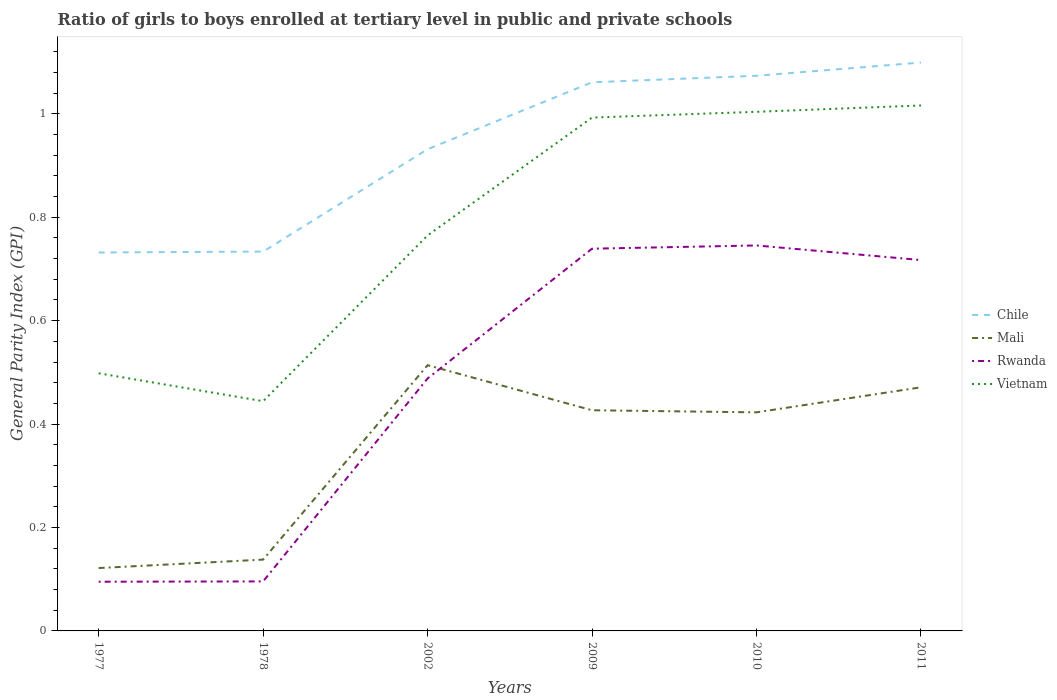Does the line corresponding to Rwanda intersect with the line corresponding to Vietnam?
Your response must be concise. No. Is the number of lines equal to the number of legend labels?
Your answer should be compact. Yes. Across all years, what is the maximum general parity index in Chile?
Make the answer very short. 0.73. What is the total general parity index in Vietnam in the graph?
Give a very brief answer. -0.02. What is the difference between the highest and the second highest general parity index in Rwanda?
Your response must be concise. 0.65. What is the difference between the highest and the lowest general parity index in Mali?
Your response must be concise. 4. Is the general parity index in Mali strictly greater than the general parity index in Chile over the years?
Make the answer very short. Yes. What is the difference between two consecutive major ticks on the Y-axis?
Provide a short and direct response. 0.2. Are the values on the major ticks of Y-axis written in scientific E-notation?
Give a very brief answer. No. Where does the legend appear in the graph?
Provide a succinct answer. Center right. How are the legend labels stacked?
Offer a terse response. Vertical. What is the title of the graph?
Your response must be concise. Ratio of girls to boys enrolled at tertiary level in public and private schools. What is the label or title of the Y-axis?
Provide a short and direct response. General Parity Index (GPI). What is the General Parity Index (GPI) in Chile in 1977?
Make the answer very short. 0.73. What is the General Parity Index (GPI) in Mali in 1977?
Ensure brevity in your answer.  0.12. What is the General Parity Index (GPI) in Rwanda in 1977?
Provide a short and direct response. 0.1. What is the General Parity Index (GPI) in Vietnam in 1977?
Your answer should be compact. 0.5. What is the General Parity Index (GPI) in Chile in 1978?
Provide a succinct answer. 0.73. What is the General Parity Index (GPI) in Mali in 1978?
Your answer should be compact. 0.14. What is the General Parity Index (GPI) of Rwanda in 1978?
Give a very brief answer. 0.1. What is the General Parity Index (GPI) of Vietnam in 1978?
Your answer should be compact. 0.44. What is the General Parity Index (GPI) of Chile in 2002?
Provide a short and direct response. 0.93. What is the General Parity Index (GPI) in Mali in 2002?
Ensure brevity in your answer.  0.51. What is the General Parity Index (GPI) in Rwanda in 2002?
Keep it short and to the point. 0.49. What is the General Parity Index (GPI) of Vietnam in 2002?
Provide a short and direct response. 0.76. What is the General Parity Index (GPI) of Chile in 2009?
Provide a succinct answer. 1.06. What is the General Parity Index (GPI) in Mali in 2009?
Ensure brevity in your answer.  0.43. What is the General Parity Index (GPI) of Rwanda in 2009?
Keep it short and to the point. 0.74. What is the General Parity Index (GPI) of Vietnam in 2009?
Provide a succinct answer. 0.99. What is the General Parity Index (GPI) in Chile in 2010?
Your response must be concise. 1.07. What is the General Parity Index (GPI) of Mali in 2010?
Ensure brevity in your answer.  0.42. What is the General Parity Index (GPI) in Rwanda in 2010?
Give a very brief answer. 0.75. What is the General Parity Index (GPI) of Vietnam in 2010?
Ensure brevity in your answer.  1. What is the General Parity Index (GPI) of Chile in 2011?
Ensure brevity in your answer.  1.1. What is the General Parity Index (GPI) of Mali in 2011?
Provide a succinct answer. 0.47. What is the General Parity Index (GPI) in Rwanda in 2011?
Your response must be concise. 0.72. What is the General Parity Index (GPI) of Vietnam in 2011?
Provide a short and direct response. 1.02. Across all years, what is the maximum General Parity Index (GPI) in Chile?
Make the answer very short. 1.1. Across all years, what is the maximum General Parity Index (GPI) in Mali?
Your answer should be very brief. 0.51. Across all years, what is the maximum General Parity Index (GPI) of Rwanda?
Your response must be concise. 0.75. Across all years, what is the maximum General Parity Index (GPI) of Vietnam?
Your answer should be compact. 1.02. Across all years, what is the minimum General Parity Index (GPI) of Chile?
Provide a short and direct response. 0.73. Across all years, what is the minimum General Parity Index (GPI) in Mali?
Give a very brief answer. 0.12. Across all years, what is the minimum General Parity Index (GPI) in Rwanda?
Offer a terse response. 0.1. Across all years, what is the minimum General Parity Index (GPI) of Vietnam?
Make the answer very short. 0.44. What is the total General Parity Index (GPI) in Chile in the graph?
Keep it short and to the point. 5.63. What is the total General Parity Index (GPI) of Mali in the graph?
Offer a very short reply. 2.09. What is the total General Parity Index (GPI) in Rwanda in the graph?
Your response must be concise. 2.88. What is the total General Parity Index (GPI) in Vietnam in the graph?
Provide a succinct answer. 4.72. What is the difference between the General Parity Index (GPI) in Chile in 1977 and that in 1978?
Make the answer very short. -0. What is the difference between the General Parity Index (GPI) in Mali in 1977 and that in 1978?
Make the answer very short. -0.02. What is the difference between the General Parity Index (GPI) of Rwanda in 1977 and that in 1978?
Offer a terse response. -0. What is the difference between the General Parity Index (GPI) in Vietnam in 1977 and that in 1978?
Your answer should be compact. 0.05. What is the difference between the General Parity Index (GPI) in Chile in 1977 and that in 2002?
Give a very brief answer. -0.2. What is the difference between the General Parity Index (GPI) of Mali in 1977 and that in 2002?
Keep it short and to the point. -0.39. What is the difference between the General Parity Index (GPI) of Rwanda in 1977 and that in 2002?
Your answer should be very brief. -0.39. What is the difference between the General Parity Index (GPI) of Vietnam in 1977 and that in 2002?
Keep it short and to the point. -0.27. What is the difference between the General Parity Index (GPI) in Chile in 1977 and that in 2009?
Your answer should be compact. -0.33. What is the difference between the General Parity Index (GPI) in Mali in 1977 and that in 2009?
Provide a short and direct response. -0.31. What is the difference between the General Parity Index (GPI) in Rwanda in 1977 and that in 2009?
Offer a terse response. -0.64. What is the difference between the General Parity Index (GPI) in Vietnam in 1977 and that in 2009?
Give a very brief answer. -0.49. What is the difference between the General Parity Index (GPI) of Chile in 1977 and that in 2010?
Your answer should be compact. -0.34. What is the difference between the General Parity Index (GPI) of Mali in 1977 and that in 2010?
Provide a succinct answer. -0.3. What is the difference between the General Parity Index (GPI) of Rwanda in 1977 and that in 2010?
Provide a short and direct response. -0.65. What is the difference between the General Parity Index (GPI) of Vietnam in 1977 and that in 2010?
Give a very brief answer. -0.51. What is the difference between the General Parity Index (GPI) of Chile in 1977 and that in 2011?
Keep it short and to the point. -0.37. What is the difference between the General Parity Index (GPI) of Mali in 1977 and that in 2011?
Your answer should be very brief. -0.35. What is the difference between the General Parity Index (GPI) of Rwanda in 1977 and that in 2011?
Make the answer very short. -0.62. What is the difference between the General Parity Index (GPI) of Vietnam in 1977 and that in 2011?
Your response must be concise. -0.52. What is the difference between the General Parity Index (GPI) in Chile in 1978 and that in 2002?
Provide a succinct answer. -0.2. What is the difference between the General Parity Index (GPI) of Mali in 1978 and that in 2002?
Offer a terse response. -0.38. What is the difference between the General Parity Index (GPI) of Rwanda in 1978 and that in 2002?
Offer a very short reply. -0.39. What is the difference between the General Parity Index (GPI) of Vietnam in 1978 and that in 2002?
Keep it short and to the point. -0.32. What is the difference between the General Parity Index (GPI) in Chile in 1978 and that in 2009?
Give a very brief answer. -0.33. What is the difference between the General Parity Index (GPI) in Mali in 1978 and that in 2009?
Your answer should be very brief. -0.29. What is the difference between the General Parity Index (GPI) of Rwanda in 1978 and that in 2009?
Provide a short and direct response. -0.64. What is the difference between the General Parity Index (GPI) in Vietnam in 1978 and that in 2009?
Your response must be concise. -0.55. What is the difference between the General Parity Index (GPI) of Chile in 1978 and that in 2010?
Give a very brief answer. -0.34. What is the difference between the General Parity Index (GPI) of Mali in 1978 and that in 2010?
Keep it short and to the point. -0.28. What is the difference between the General Parity Index (GPI) in Rwanda in 1978 and that in 2010?
Make the answer very short. -0.65. What is the difference between the General Parity Index (GPI) in Vietnam in 1978 and that in 2010?
Your answer should be compact. -0.56. What is the difference between the General Parity Index (GPI) in Chile in 1978 and that in 2011?
Your answer should be compact. -0.37. What is the difference between the General Parity Index (GPI) in Mali in 1978 and that in 2011?
Keep it short and to the point. -0.33. What is the difference between the General Parity Index (GPI) of Rwanda in 1978 and that in 2011?
Offer a terse response. -0.62. What is the difference between the General Parity Index (GPI) of Vietnam in 1978 and that in 2011?
Offer a terse response. -0.57. What is the difference between the General Parity Index (GPI) in Chile in 2002 and that in 2009?
Give a very brief answer. -0.13. What is the difference between the General Parity Index (GPI) in Mali in 2002 and that in 2009?
Ensure brevity in your answer.  0.09. What is the difference between the General Parity Index (GPI) in Rwanda in 2002 and that in 2009?
Offer a very short reply. -0.25. What is the difference between the General Parity Index (GPI) in Vietnam in 2002 and that in 2009?
Your answer should be compact. -0.23. What is the difference between the General Parity Index (GPI) in Chile in 2002 and that in 2010?
Give a very brief answer. -0.14. What is the difference between the General Parity Index (GPI) in Mali in 2002 and that in 2010?
Provide a short and direct response. 0.09. What is the difference between the General Parity Index (GPI) in Rwanda in 2002 and that in 2010?
Offer a terse response. -0.26. What is the difference between the General Parity Index (GPI) in Vietnam in 2002 and that in 2010?
Your response must be concise. -0.24. What is the difference between the General Parity Index (GPI) of Chile in 2002 and that in 2011?
Your answer should be compact. -0.17. What is the difference between the General Parity Index (GPI) in Mali in 2002 and that in 2011?
Ensure brevity in your answer.  0.04. What is the difference between the General Parity Index (GPI) in Rwanda in 2002 and that in 2011?
Your answer should be very brief. -0.23. What is the difference between the General Parity Index (GPI) in Vietnam in 2002 and that in 2011?
Offer a terse response. -0.25. What is the difference between the General Parity Index (GPI) in Chile in 2009 and that in 2010?
Offer a very short reply. -0.01. What is the difference between the General Parity Index (GPI) in Mali in 2009 and that in 2010?
Your response must be concise. 0. What is the difference between the General Parity Index (GPI) of Rwanda in 2009 and that in 2010?
Your answer should be very brief. -0.01. What is the difference between the General Parity Index (GPI) in Vietnam in 2009 and that in 2010?
Provide a succinct answer. -0.01. What is the difference between the General Parity Index (GPI) of Chile in 2009 and that in 2011?
Your answer should be very brief. -0.04. What is the difference between the General Parity Index (GPI) in Mali in 2009 and that in 2011?
Your response must be concise. -0.04. What is the difference between the General Parity Index (GPI) in Rwanda in 2009 and that in 2011?
Your response must be concise. 0.02. What is the difference between the General Parity Index (GPI) in Vietnam in 2009 and that in 2011?
Offer a terse response. -0.02. What is the difference between the General Parity Index (GPI) in Chile in 2010 and that in 2011?
Your answer should be very brief. -0.03. What is the difference between the General Parity Index (GPI) of Mali in 2010 and that in 2011?
Provide a succinct answer. -0.05. What is the difference between the General Parity Index (GPI) of Rwanda in 2010 and that in 2011?
Give a very brief answer. 0.03. What is the difference between the General Parity Index (GPI) in Vietnam in 2010 and that in 2011?
Keep it short and to the point. -0.01. What is the difference between the General Parity Index (GPI) in Chile in 1977 and the General Parity Index (GPI) in Mali in 1978?
Your answer should be compact. 0.59. What is the difference between the General Parity Index (GPI) in Chile in 1977 and the General Parity Index (GPI) in Rwanda in 1978?
Provide a succinct answer. 0.64. What is the difference between the General Parity Index (GPI) in Chile in 1977 and the General Parity Index (GPI) in Vietnam in 1978?
Keep it short and to the point. 0.29. What is the difference between the General Parity Index (GPI) of Mali in 1977 and the General Parity Index (GPI) of Rwanda in 1978?
Offer a terse response. 0.03. What is the difference between the General Parity Index (GPI) of Mali in 1977 and the General Parity Index (GPI) of Vietnam in 1978?
Give a very brief answer. -0.32. What is the difference between the General Parity Index (GPI) in Rwanda in 1977 and the General Parity Index (GPI) in Vietnam in 1978?
Provide a succinct answer. -0.35. What is the difference between the General Parity Index (GPI) in Chile in 1977 and the General Parity Index (GPI) in Mali in 2002?
Your response must be concise. 0.22. What is the difference between the General Parity Index (GPI) of Chile in 1977 and the General Parity Index (GPI) of Rwanda in 2002?
Provide a succinct answer. 0.24. What is the difference between the General Parity Index (GPI) of Chile in 1977 and the General Parity Index (GPI) of Vietnam in 2002?
Provide a succinct answer. -0.03. What is the difference between the General Parity Index (GPI) of Mali in 1977 and the General Parity Index (GPI) of Rwanda in 2002?
Keep it short and to the point. -0.37. What is the difference between the General Parity Index (GPI) in Mali in 1977 and the General Parity Index (GPI) in Vietnam in 2002?
Ensure brevity in your answer.  -0.64. What is the difference between the General Parity Index (GPI) of Rwanda in 1977 and the General Parity Index (GPI) of Vietnam in 2002?
Provide a short and direct response. -0.67. What is the difference between the General Parity Index (GPI) of Chile in 1977 and the General Parity Index (GPI) of Mali in 2009?
Provide a short and direct response. 0.31. What is the difference between the General Parity Index (GPI) in Chile in 1977 and the General Parity Index (GPI) in Rwanda in 2009?
Your response must be concise. -0.01. What is the difference between the General Parity Index (GPI) in Chile in 1977 and the General Parity Index (GPI) in Vietnam in 2009?
Your answer should be compact. -0.26. What is the difference between the General Parity Index (GPI) in Mali in 1977 and the General Parity Index (GPI) in Rwanda in 2009?
Provide a short and direct response. -0.62. What is the difference between the General Parity Index (GPI) in Mali in 1977 and the General Parity Index (GPI) in Vietnam in 2009?
Offer a very short reply. -0.87. What is the difference between the General Parity Index (GPI) in Rwanda in 1977 and the General Parity Index (GPI) in Vietnam in 2009?
Provide a short and direct response. -0.9. What is the difference between the General Parity Index (GPI) in Chile in 1977 and the General Parity Index (GPI) in Mali in 2010?
Offer a very short reply. 0.31. What is the difference between the General Parity Index (GPI) of Chile in 1977 and the General Parity Index (GPI) of Rwanda in 2010?
Offer a terse response. -0.01. What is the difference between the General Parity Index (GPI) in Chile in 1977 and the General Parity Index (GPI) in Vietnam in 2010?
Make the answer very short. -0.27. What is the difference between the General Parity Index (GPI) of Mali in 1977 and the General Parity Index (GPI) of Rwanda in 2010?
Ensure brevity in your answer.  -0.62. What is the difference between the General Parity Index (GPI) of Mali in 1977 and the General Parity Index (GPI) of Vietnam in 2010?
Offer a very short reply. -0.88. What is the difference between the General Parity Index (GPI) of Rwanda in 1977 and the General Parity Index (GPI) of Vietnam in 2010?
Your response must be concise. -0.91. What is the difference between the General Parity Index (GPI) in Chile in 1977 and the General Parity Index (GPI) in Mali in 2011?
Ensure brevity in your answer.  0.26. What is the difference between the General Parity Index (GPI) of Chile in 1977 and the General Parity Index (GPI) of Rwanda in 2011?
Make the answer very short. 0.01. What is the difference between the General Parity Index (GPI) in Chile in 1977 and the General Parity Index (GPI) in Vietnam in 2011?
Ensure brevity in your answer.  -0.28. What is the difference between the General Parity Index (GPI) of Mali in 1977 and the General Parity Index (GPI) of Rwanda in 2011?
Provide a succinct answer. -0.6. What is the difference between the General Parity Index (GPI) of Mali in 1977 and the General Parity Index (GPI) of Vietnam in 2011?
Provide a succinct answer. -0.89. What is the difference between the General Parity Index (GPI) in Rwanda in 1977 and the General Parity Index (GPI) in Vietnam in 2011?
Ensure brevity in your answer.  -0.92. What is the difference between the General Parity Index (GPI) of Chile in 1978 and the General Parity Index (GPI) of Mali in 2002?
Keep it short and to the point. 0.22. What is the difference between the General Parity Index (GPI) of Chile in 1978 and the General Parity Index (GPI) of Rwanda in 2002?
Your answer should be compact. 0.25. What is the difference between the General Parity Index (GPI) in Chile in 1978 and the General Parity Index (GPI) in Vietnam in 2002?
Provide a succinct answer. -0.03. What is the difference between the General Parity Index (GPI) of Mali in 1978 and the General Parity Index (GPI) of Rwanda in 2002?
Offer a terse response. -0.35. What is the difference between the General Parity Index (GPI) of Mali in 1978 and the General Parity Index (GPI) of Vietnam in 2002?
Your answer should be very brief. -0.63. What is the difference between the General Parity Index (GPI) in Rwanda in 1978 and the General Parity Index (GPI) in Vietnam in 2002?
Your answer should be compact. -0.67. What is the difference between the General Parity Index (GPI) of Chile in 1978 and the General Parity Index (GPI) of Mali in 2009?
Give a very brief answer. 0.31. What is the difference between the General Parity Index (GPI) in Chile in 1978 and the General Parity Index (GPI) in Rwanda in 2009?
Give a very brief answer. -0.01. What is the difference between the General Parity Index (GPI) in Chile in 1978 and the General Parity Index (GPI) in Vietnam in 2009?
Provide a short and direct response. -0.26. What is the difference between the General Parity Index (GPI) of Mali in 1978 and the General Parity Index (GPI) of Rwanda in 2009?
Keep it short and to the point. -0.6. What is the difference between the General Parity Index (GPI) of Mali in 1978 and the General Parity Index (GPI) of Vietnam in 2009?
Provide a short and direct response. -0.85. What is the difference between the General Parity Index (GPI) of Rwanda in 1978 and the General Parity Index (GPI) of Vietnam in 2009?
Offer a very short reply. -0.9. What is the difference between the General Parity Index (GPI) of Chile in 1978 and the General Parity Index (GPI) of Mali in 2010?
Keep it short and to the point. 0.31. What is the difference between the General Parity Index (GPI) of Chile in 1978 and the General Parity Index (GPI) of Rwanda in 2010?
Your answer should be compact. -0.01. What is the difference between the General Parity Index (GPI) in Chile in 1978 and the General Parity Index (GPI) in Vietnam in 2010?
Offer a very short reply. -0.27. What is the difference between the General Parity Index (GPI) in Mali in 1978 and the General Parity Index (GPI) in Rwanda in 2010?
Your response must be concise. -0.61. What is the difference between the General Parity Index (GPI) in Mali in 1978 and the General Parity Index (GPI) in Vietnam in 2010?
Offer a very short reply. -0.87. What is the difference between the General Parity Index (GPI) in Rwanda in 1978 and the General Parity Index (GPI) in Vietnam in 2010?
Your answer should be very brief. -0.91. What is the difference between the General Parity Index (GPI) in Chile in 1978 and the General Parity Index (GPI) in Mali in 2011?
Ensure brevity in your answer.  0.26. What is the difference between the General Parity Index (GPI) of Chile in 1978 and the General Parity Index (GPI) of Rwanda in 2011?
Offer a very short reply. 0.02. What is the difference between the General Parity Index (GPI) in Chile in 1978 and the General Parity Index (GPI) in Vietnam in 2011?
Provide a succinct answer. -0.28. What is the difference between the General Parity Index (GPI) in Mali in 1978 and the General Parity Index (GPI) in Rwanda in 2011?
Give a very brief answer. -0.58. What is the difference between the General Parity Index (GPI) of Mali in 1978 and the General Parity Index (GPI) of Vietnam in 2011?
Make the answer very short. -0.88. What is the difference between the General Parity Index (GPI) in Rwanda in 1978 and the General Parity Index (GPI) in Vietnam in 2011?
Ensure brevity in your answer.  -0.92. What is the difference between the General Parity Index (GPI) of Chile in 2002 and the General Parity Index (GPI) of Mali in 2009?
Offer a terse response. 0.5. What is the difference between the General Parity Index (GPI) of Chile in 2002 and the General Parity Index (GPI) of Rwanda in 2009?
Ensure brevity in your answer.  0.19. What is the difference between the General Parity Index (GPI) in Chile in 2002 and the General Parity Index (GPI) in Vietnam in 2009?
Provide a short and direct response. -0.06. What is the difference between the General Parity Index (GPI) of Mali in 2002 and the General Parity Index (GPI) of Rwanda in 2009?
Offer a very short reply. -0.23. What is the difference between the General Parity Index (GPI) of Mali in 2002 and the General Parity Index (GPI) of Vietnam in 2009?
Provide a succinct answer. -0.48. What is the difference between the General Parity Index (GPI) in Rwanda in 2002 and the General Parity Index (GPI) in Vietnam in 2009?
Your answer should be compact. -0.5. What is the difference between the General Parity Index (GPI) in Chile in 2002 and the General Parity Index (GPI) in Mali in 2010?
Offer a terse response. 0.51. What is the difference between the General Parity Index (GPI) of Chile in 2002 and the General Parity Index (GPI) of Rwanda in 2010?
Provide a succinct answer. 0.19. What is the difference between the General Parity Index (GPI) of Chile in 2002 and the General Parity Index (GPI) of Vietnam in 2010?
Offer a very short reply. -0.07. What is the difference between the General Parity Index (GPI) of Mali in 2002 and the General Parity Index (GPI) of Rwanda in 2010?
Keep it short and to the point. -0.23. What is the difference between the General Parity Index (GPI) of Mali in 2002 and the General Parity Index (GPI) of Vietnam in 2010?
Your response must be concise. -0.49. What is the difference between the General Parity Index (GPI) in Rwanda in 2002 and the General Parity Index (GPI) in Vietnam in 2010?
Provide a succinct answer. -0.52. What is the difference between the General Parity Index (GPI) of Chile in 2002 and the General Parity Index (GPI) of Mali in 2011?
Your answer should be compact. 0.46. What is the difference between the General Parity Index (GPI) in Chile in 2002 and the General Parity Index (GPI) in Rwanda in 2011?
Provide a short and direct response. 0.21. What is the difference between the General Parity Index (GPI) of Chile in 2002 and the General Parity Index (GPI) of Vietnam in 2011?
Provide a short and direct response. -0.08. What is the difference between the General Parity Index (GPI) of Mali in 2002 and the General Parity Index (GPI) of Rwanda in 2011?
Your answer should be compact. -0.2. What is the difference between the General Parity Index (GPI) in Mali in 2002 and the General Parity Index (GPI) in Vietnam in 2011?
Your answer should be compact. -0.5. What is the difference between the General Parity Index (GPI) in Rwanda in 2002 and the General Parity Index (GPI) in Vietnam in 2011?
Give a very brief answer. -0.53. What is the difference between the General Parity Index (GPI) in Chile in 2009 and the General Parity Index (GPI) in Mali in 2010?
Your response must be concise. 0.64. What is the difference between the General Parity Index (GPI) in Chile in 2009 and the General Parity Index (GPI) in Rwanda in 2010?
Offer a terse response. 0.32. What is the difference between the General Parity Index (GPI) of Chile in 2009 and the General Parity Index (GPI) of Vietnam in 2010?
Keep it short and to the point. 0.06. What is the difference between the General Parity Index (GPI) in Mali in 2009 and the General Parity Index (GPI) in Rwanda in 2010?
Offer a terse response. -0.32. What is the difference between the General Parity Index (GPI) of Mali in 2009 and the General Parity Index (GPI) of Vietnam in 2010?
Your answer should be compact. -0.58. What is the difference between the General Parity Index (GPI) of Rwanda in 2009 and the General Parity Index (GPI) of Vietnam in 2010?
Your response must be concise. -0.26. What is the difference between the General Parity Index (GPI) in Chile in 2009 and the General Parity Index (GPI) in Mali in 2011?
Offer a terse response. 0.59. What is the difference between the General Parity Index (GPI) of Chile in 2009 and the General Parity Index (GPI) of Rwanda in 2011?
Provide a succinct answer. 0.34. What is the difference between the General Parity Index (GPI) of Chile in 2009 and the General Parity Index (GPI) of Vietnam in 2011?
Offer a very short reply. 0.04. What is the difference between the General Parity Index (GPI) of Mali in 2009 and the General Parity Index (GPI) of Rwanda in 2011?
Ensure brevity in your answer.  -0.29. What is the difference between the General Parity Index (GPI) of Mali in 2009 and the General Parity Index (GPI) of Vietnam in 2011?
Provide a short and direct response. -0.59. What is the difference between the General Parity Index (GPI) in Rwanda in 2009 and the General Parity Index (GPI) in Vietnam in 2011?
Provide a succinct answer. -0.28. What is the difference between the General Parity Index (GPI) of Chile in 2010 and the General Parity Index (GPI) of Mali in 2011?
Ensure brevity in your answer.  0.6. What is the difference between the General Parity Index (GPI) of Chile in 2010 and the General Parity Index (GPI) of Rwanda in 2011?
Give a very brief answer. 0.36. What is the difference between the General Parity Index (GPI) of Chile in 2010 and the General Parity Index (GPI) of Vietnam in 2011?
Your answer should be compact. 0.06. What is the difference between the General Parity Index (GPI) of Mali in 2010 and the General Parity Index (GPI) of Rwanda in 2011?
Offer a terse response. -0.29. What is the difference between the General Parity Index (GPI) in Mali in 2010 and the General Parity Index (GPI) in Vietnam in 2011?
Your answer should be compact. -0.59. What is the difference between the General Parity Index (GPI) in Rwanda in 2010 and the General Parity Index (GPI) in Vietnam in 2011?
Ensure brevity in your answer.  -0.27. What is the average General Parity Index (GPI) of Chile per year?
Provide a short and direct response. 0.94. What is the average General Parity Index (GPI) in Mali per year?
Your response must be concise. 0.35. What is the average General Parity Index (GPI) of Rwanda per year?
Your answer should be compact. 0.48. What is the average General Parity Index (GPI) in Vietnam per year?
Keep it short and to the point. 0.79. In the year 1977, what is the difference between the General Parity Index (GPI) in Chile and General Parity Index (GPI) in Mali?
Your response must be concise. 0.61. In the year 1977, what is the difference between the General Parity Index (GPI) in Chile and General Parity Index (GPI) in Rwanda?
Ensure brevity in your answer.  0.64. In the year 1977, what is the difference between the General Parity Index (GPI) in Chile and General Parity Index (GPI) in Vietnam?
Offer a very short reply. 0.23. In the year 1977, what is the difference between the General Parity Index (GPI) in Mali and General Parity Index (GPI) in Rwanda?
Offer a very short reply. 0.03. In the year 1977, what is the difference between the General Parity Index (GPI) in Mali and General Parity Index (GPI) in Vietnam?
Provide a succinct answer. -0.38. In the year 1977, what is the difference between the General Parity Index (GPI) of Rwanda and General Parity Index (GPI) of Vietnam?
Make the answer very short. -0.4. In the year 1978, what is the difference between the General Parity Index (GPI) in Chile and General Parity Index (GPI) in Mali?
Your answer should be compact. 0.6. In the year 1978, what is the difference between the General Parity Index (GPI) of Chile and General Parity Index (GPI) of Rwanda?
Your response must be concise. 0.64. In the year 1978, what is the difference between the General Parity Index (GPI) in Chile and General Parity Index (GPI) in Vietnam?
Provide a succinct answer. 0.29. In the year 1978, what is the difference between the General Parity Index (GPI) of Mali and General Parity Index (GPI) of Rwanda?
Provide a succinct answer. 0.04. In the year 1978, what is the difference between the General Parity Index (GPI) in Mali and General Parity Index (GPI) in Vietnam?
Make the answer very short. -0.31. In the year 1978, what is the difference between the General Parity Index (GPI) in Rwanda and General Parity Index (GPI) in Vietnam?
Make the answer very short. -0.35. In the year 2002, what is the difference between the General Parity Index (GPI) in Chile and General Parity Index (GPI) in Mali?
Your response must be concise. 0.42. In the year 2002, what is the difference between the General Parity Index (GPI) in Chile and General Parity Index (GPI) in Rwanda?
Make the answer very short. 0.44. In the year 2002, what is the difference between the General Parity Index (GPI) in Chile and General Parity Index (GPI) in Vietnam?
Keep it short and to the point. 0.17. In the year 2002, what is the difference between the General Parity Index (GPI) of Mali and General Parity Index (GPI) of Rwanda?
Your response must be concise. 0.03. In the year 2002, what is the difference between the General Parity Index (GPI) in Mali and General Parity Index (GPI) in Vietnam?
Provide a short and direct response. -0.25. In the year 2002, what is the difference between the General Parity Index (GPI) of Rwanda and General Parity Index (GPI) of Vietnam?
Your answer should be compact. -0.28. In the year 2009, what is the difference between the General Parity Index (GPI) of Chile and General Parity Index (GPI) of Mali?
Your response must be concise. 0.63. In the year 2009, what is the difference between the General Parity Index (GPI) in Chile and General Parity Index (GPI) in Rwanda?
Your response must be concise. 0.32. In the year 2009, what is the difference between the General Parity Index (GPI) in Chile and General Parity Index (GPI) in Vietnam?
Provide a short and direct response. 0.07. In the year 2009, what is the difference between the General Parity Index (GPI) of Mali and General Parity Index (GPI) of Rwanda?
Provide a succinct answer. -0.31. In the year 2009, what is the difference between the General Parity Index (GPI) of Mali and General Parity Index (GPI) of Vietnam?
Make the answer very short. -0.57. In the year 2009, what is the difference between the General Parity Index (GPI) of Rwanda and General Parity Index (GPI) of Vietnam?
Keep it short and to the point. -0.25. In the year 2010, what is the difference between the General Parity Index (GPI) in Chile and General Parity Index (GPI) in Mali?
Offer a very short reply. 0.65. In the year 2010, what is the difference between the General Parity Index (GPI) in Chile and General Parity Index (GPI) in Rwanda?
Your answer should be compact. 0.33. In the year 2010, what is the difference between the General Parity Index (GPI) in Chile and General Parity Index (GPI) in Vietnam?
Make the answer very short. 0.07. In the year 2010, what is the difference between the General Parity Index (GPI) of Mali and General Parity Index (GPI) of Rwanda?
Keep it short and to the point. -0.32. In the year 2010, what is the difference between the General Parity Index (GPI) in Mali and General Parity Index (GPI) in Vietnam?
Your answer should be compact. -0.58. In the year 2010, what is the difference between the General Parity Index (GPI) in Rwanda and General Parity Index (GPI) in Vietnam?
Make the answer very short. -0.26. In the year 2011, what is the difference between the General Parity Index (GPI) of Chile and General Parity Index (GPI) of Mali?
Make the answer very short. 0.63. In the year 2011, what is the difference between the General Parity Index (GPI) of Chile and General Parity Index (GPI) of Rwanda?
Give a very brief answer. 0.38. In the year 2011, what is the difference between the General Parity Index (GPI) of Chile and General Parity Index (GPI) of Vietnam?
Provide a short and direct response. 0.08. In the year 2011, what is the difference between the General Parity Index (GPI) of Mali and General Parity Index (GPI) of Rwanda?
Make the answer very short. -0.25. In the year 2011, what is the difference between the General Parity Index (GPI) of Mali and General Parity Index (GPI) of Vietnam?
Make the answer very short. -0.55. In the year 2011, what is the difference between the General Parity Index (GPI) in Rwanda and General Parity Index (GPI) in Vietnam?
Keep it short and to the point. -0.3. What is the ratio of the General Parity Index (GPI) of Chile in 1977 to that in 1978?
Offer a very short reply. 1. What is the ratio of the General Parity Index (GPI) in Mali in 1977 to that in 1978?
Provide a short and direct response. 0.88. What is the ratio of the General Parity Index (GPI) of Rwanda in 1977 to that in 1978?
Provide a short and direct response. 0.99. What is the ratio of the General Parity Index (GPI) of Vietnam in 1977 to that in 1978?
Your answer should be very brief. 1.12. What is the ratio of the General Parity Index (GPI) of Chile in 1977 to that in 2002?
Offer a terse response. 0.79. What is the ratio of the General Parity Index (GPI) in Mali in 1977 to that in 2002?
Provide a short and direct response. 0.24. What is the ratio of the General Parity Index (GPI) in Rwanda in 1977 to that in 2002?
Your answer should be very brief. 0.19. What is the ratio of the General Parity Index (GPI) of Vietnam in 1977 to that in 2002?
Give a very brief answer. 0.65. What is the ratio of the General Parity Index (GPI) in Chile in 1977 to that in 2009?
Make the answer very short. 0.69. What is the ratio of the General Parity Index (GPI) of Mali in 1977 to that in 2009?
Keep it short and to the point. 0.28. What is the ratio of the General Parity Index (GPI) of Rwanda in 1977 to that in 2009?
Your answer should be compact. 0.13. What is the ratio of the General Parity Index (GPI) of Vietnam in 1977 to that in 2009?
Your response must be concise. 0.5. What is the ratio of the General Parity Index (GPI) of Chile in 1977 to that in 2010?
Make the answer very short. 0.68. What is the ratio of the General Parity Index (GPI) of Mali in 1977 to that in 2010?
Your answer should be very brief. 0.29. What is the ratio of the General Parity Index (GPI) of Rwanda in 1977 to that in 2010?
Keep it short and to the point. 0.13. What is the ratio of the General Parity Index (GPI) in Vietnam in 1977 to that in 2010?
Make the answer very short. 0.5. What is the ratio of the General Parity Index (GPI) in Chile in 1977 to that in 2011?
Offer a very short reply. 0.67. What is the ratio of the General Parity Index (GPI) of Mali in 1977 to that in 2011?
Provide a succinct answer. 0.26. What is the ratio of the General Parity Index (GPI) in Rwanda in 1977 to that in 2011?
Offer a very short reply. 0.13. What is the ratio of the General Parity Index (GPI) in Vietnam in 1977 to that in 2011?
Offer a very short reply. 0.49. What is the ratio of the General Parity Index (GPI) of Chile in 1978 to that in 2002?
Provide a succinct answer. 0.79. What is the ratio of the General Parity Index (GPI) in Mali in 1978 to that in 2002?
Offer a terse response. 0.27. What is the ratio of the General Parity Index (GPI) of Rwanda in 1978 to that in 2002?
Your response must be concise. 0.2. What is the ratio of the General Parity Index (GPI) of Vietnam in 1978 to that in 2002?
Offer a very short reply. 0.58. What is the ratio of the General Parity Index (GPI) in Chile in 1978 to that in 2009?
Your answer should be very brief. 0.69. What is the ratio of the General Parity Index (GPI) of Mali in 1978 to that in 2009?
Your answer should be compact. 0.32. What is the ratio of the General Parity Index (GPI) in Rwanda in 1978 to that in 2009?
Give a very brief answer. 0.13. What is the ratio of the General Parity Index (GPI) in Vietnam in 1978 to that in 2009?
Give a very brief answer. 0.45. What is the ratio of the General Parity Index (GPI) in Chile in 1978 to that in 2010?
Your answer should be very brief. 0.68. What is the ratio of the General Parity Index (GPI) in Mali in 1978 to that in 2010?
Give a very brief answer. 0.33. What is the ratio of the General Parity Index (GPI) of Rwanda in 1978 to that in 2010?
Give a very brief answer. 0.13. What is the ratio of the General Parity Index (GPI) of Vietnam in 1978 to that in 2010?
Provide a short and direct response. 0.44. What is the ratio of the General Parity Index (GPI) in Chile in 1978 to that in 2011?
Your answer should be very brief. 0.67. What is the ratio of the General Parity Index (GPI) in Mali in 1978 to that in 2011?
Your response must be concise. 0.29. What is the ratio of the General Parity Index (GPI) in Rwanda in 1978 to that in 2011?
Keep it short and to the point. 0.13. What is the ratio of the General Parity Index (GPI) of Vietnam in 1978 to that in 2011?
Keep it short and to the point. 0.44. What is the ratio of the General Parity Index (GPI) in Chile in 2002 to that in 2009?
Your answer should be very brief. 0.88. What is the ratio of the General Parity Index (GPI) in Mali in 2002 to that in 2009?
Ensure brevity in your answer.  1.2. What is the ratio of the General Parity Index (GPI) of Rwanda in 2002 to that in 2009?
Your answer should be very brief. 0.66. What is the ratio of the General Parity Index (GPI) of Vietnam in 2002 to that in 2009?
Keep it short and to the point. 0.77. What is the ratio of the General Parity Index (GPI) in Chile in 2002 to that in 2010?
Provide a succinct answer. 0.87. What is the ratio of the General Parity Index (GPI) in Mali in 2002 to that in 2010?
Your answer should be very brief. 1.22. What is the ratio of the General Parity Index (GPI) of Rwanda in 2002 to that in 2010?
Offer a terse response. 0.65. What is the ratio of the General Parity Index (GPI) of Vietnam in 2002 to that in 2010?
Provide a short and direct response. 0.76. What is the ratio of the General Parity Index (GPI) in Chile in 2002 to that in 2011?
Give a very brief answer. 0.85. What is the ratio of the General Parity Index (GPI) in Mali in 2002 to that in 2011?
Your answer should be compact. 1.09. What is the ratio of the General Parity Index (GPI) of Rwanda in 2002 to that in 2011?
Your response must be concise. 0.68. What is the ratio of the General Parity Index (GPI) of Vietnam in 2002 to that in 2011?
Ensure brevity in your answer.  0.75. What is the ratio of the General Parity Index (GPI) in Chile in 2009 to that in 2010?
Ensure brevity in your answer.  0.99. What is the ratio of the General Parity Index (GPI) of Mali in 2009 to that in 2010?
Provide a succinct answer. 1.01. What is the ratio of the General Parity Index (GPI) in Rwanda in 2009 to that in 2010?
Make the answer very short. 0.99. What is the ratio of the General Parity Index (GPI) in Vietnam in 2009 to that in 2010?
Offer a very short reply. 0.99. What is the ratio of the General Parity Index (GPI) in Chile in 2009 to that in 2011?
Your response must be concise. 0.97. What is the ratio of the General Parity Index (GPI) of Mali in 2009 to that in 2011?
Provide a succinct answer. 0.91. What is the ratio of the General Parity Index (GPI) of Rwanda in 2009 to that in 2011?
Your answer should be compact. 1.03. What is the ratio of the General Parity Index (GPI) of Chile in 2010 to that in 2011?
Make the answer very short. 0.98. What is the ratio of the General Parity Index (GPI) in Mali in 2010 to that in 2011?
Give a very brief answer. 0.9. What is the ratio of the General Parity Index (GPI) in Rwanda in 2010 to that in 2011?
Make the answer very short. 1.04. What is the ratio of the General Parity Index (GPI) in Vietnam in 2010 to that in 2011?
Offer a terse response. 0.99. What is the difference between the highest and the second highest General Parity Index (GPI) of Chile?
Keep it short and to the point. 0.03. What is the difference between the highest and the second highest General Parity Index (GPI) in Mali?
Make the answer very short. 0.04. What is the difference between the highest and the second highest General Parity Index (GPI) in Rwanda?
Offer a very short reply. 0.01. What is the difference between the highest and the second highest General Parity Index (GPI) in Vietnam?
Provide a succinct answer. 0.01. What is the difference between the highest and the lowest General Parity Index (GPI) of Chile?
Keep it short and to the point. 0.37. What is the difference between the highest and the lowest General Parity Index (GPI) in Mali?
Offer a very short reply. 0.39. What is the difference between the highest and the lowest General Parity Index (GPI) in Rwanda?
Your answer should be compact. 0.65. What is the difference between the highest and the lowest General Parity Index (GPI) in Vietnam?
Your response must be concise. 0.57. 